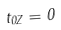Convert formula to latex. <formula><loc_0><loc_0><loc_500><loc_500>t _ { 0 Z } = 0</formula> 